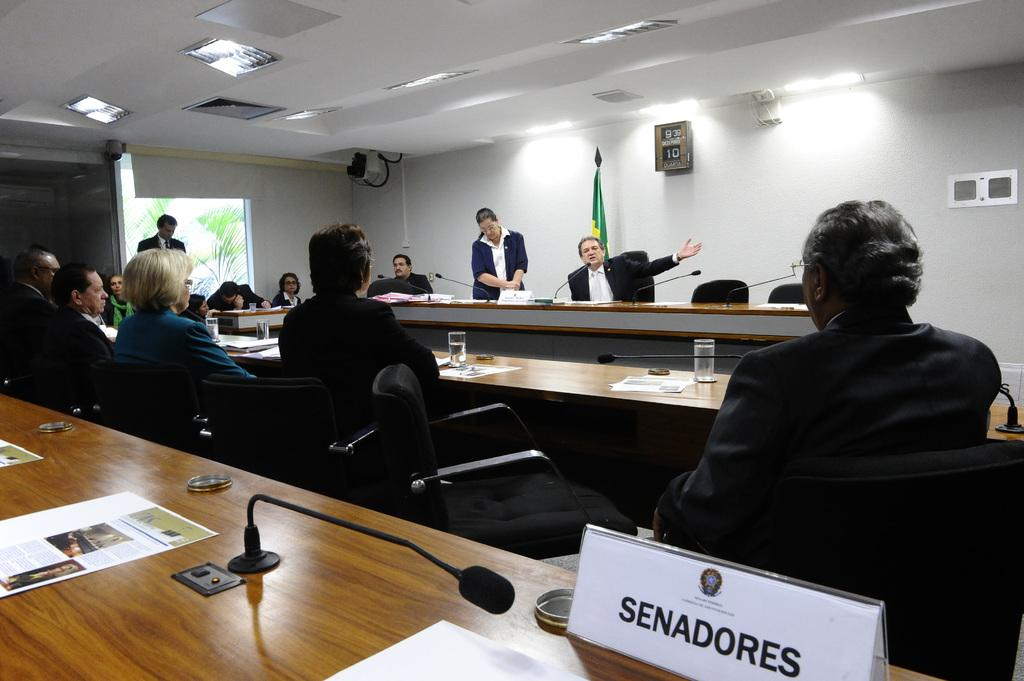<image>
Relay a brief, clear account of the picture shown. An identification tag for a Senadores is on a wooden table at a meeting. 